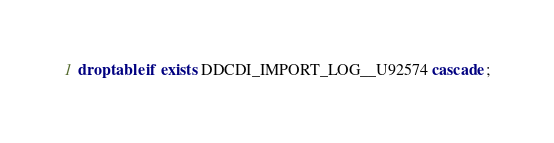Convert code to text. <code><loc_0><loc_0><loc_500><loc_500><_SQL_>drop table if exists DDCDI_IMPORT_LOG__U92574 cascade ;</code> 